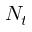<formula> <loc_0><loc_0><loc_500><loc_500>N _ { t }</formula> 